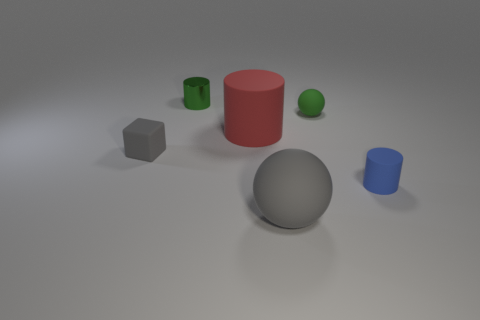Add 2 green objects. How many objects exist? 8 Subtract all blocks. How many objects are left? 5 Subtract all red cylinders. Subtract all metallic things. How many objects are left? 4 Add 1 red matte cylinders. How many red matte cylinders are left? 2 Add 6 big matte objects. How many big matte objects exist? 8 Subtract 1 gray cubes. How many objects are left? 5 